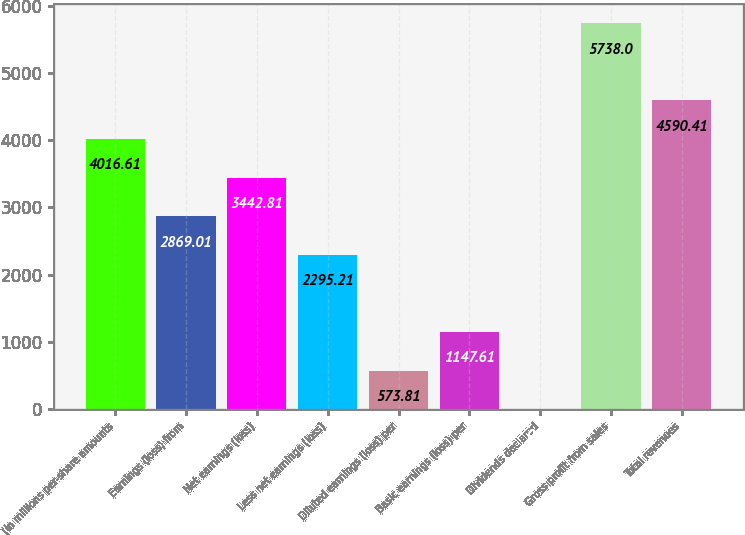Convert chart. <chart><loc_0><loc_0><loc_500><loc_500><bar_chart><fcel>(In millions per-share amounts<fcel>Earnings (loss) from<fcel>Net earnings (loss)<fcel>Less net earnings (loss)<fcel>Diluted earnings (loss) per<fcel>Basic earnings (loss) per<fcel>Dividends declared<fcel>Gross profit from sales<fcel>Total revenues<nl><fcel>4016.61<fcel>2869.01<fcel>3442.81<fcel>2295.21<fcel>573.81<fcel>1147.61<fcel>0.01<fcel>5738<fcel>4590.41<nl></chart> 